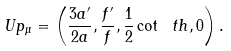<formula> <loc_0><loc_0><loc_500><loc_500>\ U p _ { \mu } = \left ( \frac { 3 a ^ { \prime } } { 2 a } , \frac { f ^ { \prime } } f , \frac { 1 } { 2 } \cot \ t h , 0 \right ) .</formula> 